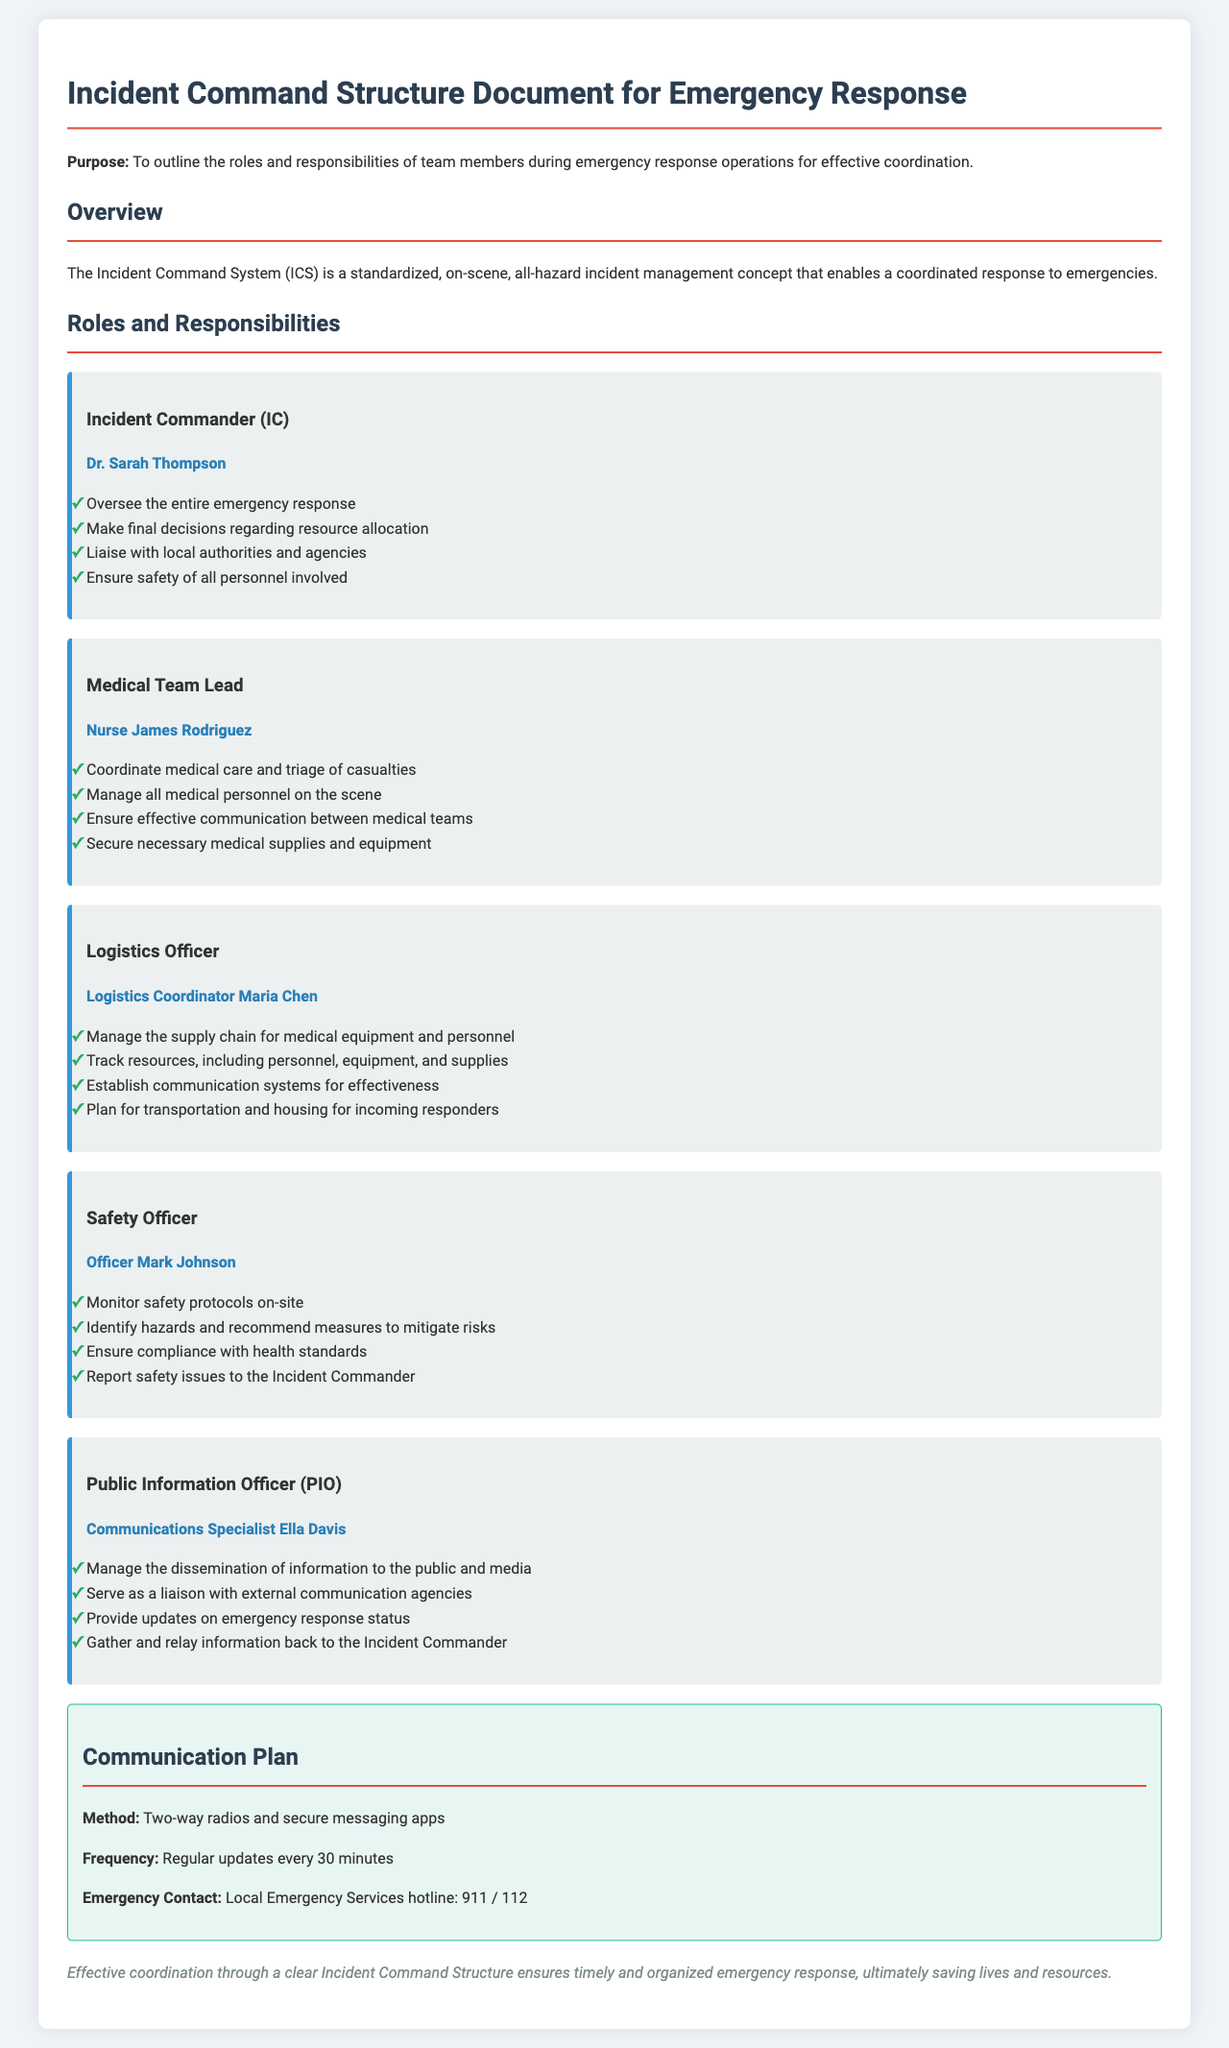What is the title of the document? The title of the document is stated clearly at the top, summarizing its content regarding emergency response operations.
Answer: Incident Command Structure Document for Emergency Response Who is the Incident Commander? The document lists the person in charge of overseeing the entire emergency response under their designated role.
Answer: Dr. Sarah Thompson What are the main communication methods mentioned? The communication plan outlines the methods used for effective information exchange during the emergency response.
Answer: Two-way radios and secure messaging apps How often are updates provided according to the communication plan? The frequency of information updates is specified in the communication plan to ensure timely coordination.
Answer: Every 30 minutes What is one of the responsibilities of the Medical Team Lead? The responsibilities section of the document highlights important duties of the Medical Team Lead.
Answer: Coordinate medical care and triage of casualties Which officer is responsible for monitoring safety protocols? The document identifies a specific role that focuses on safety during the emergency response.
Answer: Safety Officer What role does the Public Information Officer have? The document outlines the responsibilities of the Public Information Officer in managing information dissemination.
Answer: Manage the dissemination of information to the public and media What should the Safety Officer ensure compliance with? One of the responsibilities stated in the document indicates what the Safety Officer must adhere to.
Answer: Health standards What is the purpose of the Incident Command Structure Document? The purpose is clearly mentioned at the beginning of the document, indicating its importance.
Answer: To outline the roles and responsibilities of team members during emergency response operations for effective coordination 